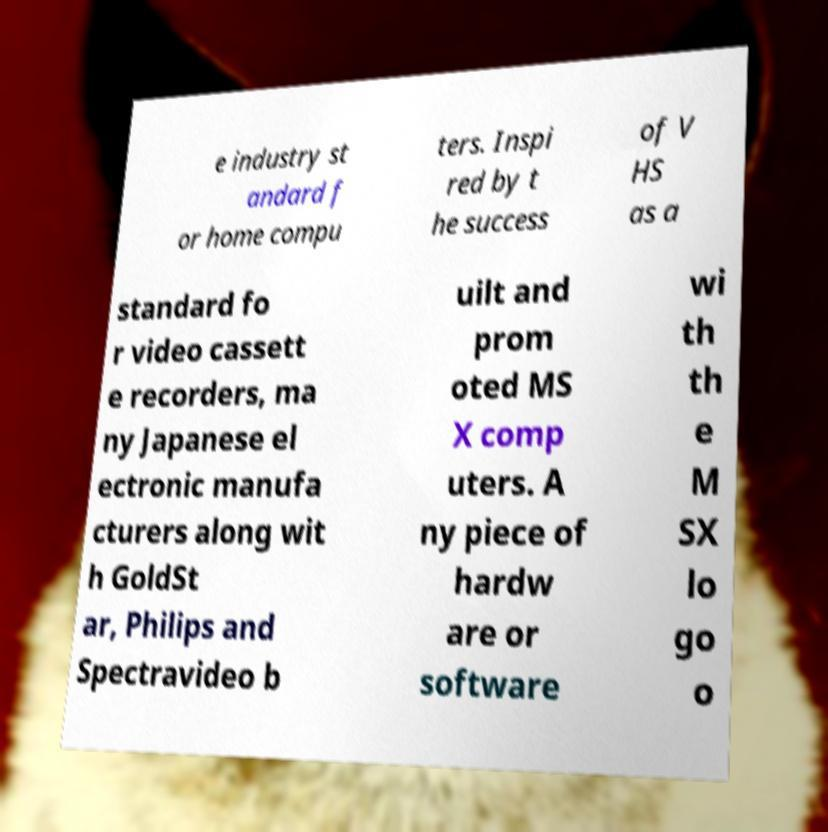Can you read and provide the text displayed in the image?This photo seems to have some interesting text. Can you extract and type it out for me? e industry st andard f or home compu ters. Inspi red by t he success of V HS as a standard fo r video cassett e recorders, ma ny Japanese el ectronic manufa cturers along wit h GoldSt ar, Philips and Spectravideo b uilt and prom oted MS X comp uters. A ny piece of hardw are or software wi th th e M SX lo go o 